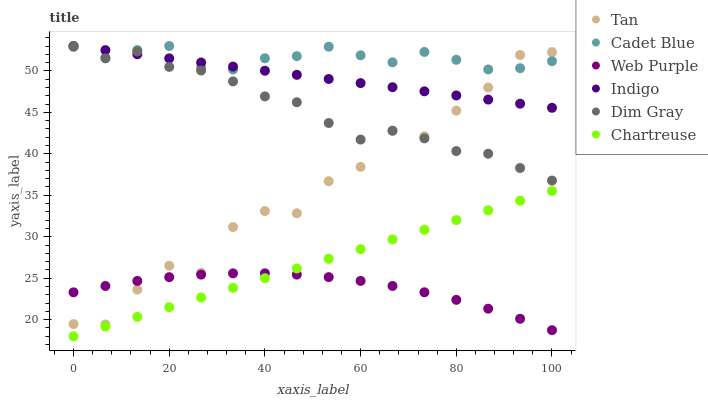Does Web Purple have the minimum area under the curve?
Answer yes or no. Yes. Does Cadet Blue have the maximum area under the curve?
Answer yes or no. Yes. Does Indigo have the minimum area under the curve?
Answer yes or no. No. Does Indigo have the maximum area under the curve?
Answer yes or no. No. Is Indigo the smoothest?
Answer yes or no. Yes. Is Tan the roughest?
Answer yes or no. Yes. Is Web Purple the smoothest?
Answer yes or no. No. Is Web Purple the roughest?
Answer yes or no. No. Does Chartreuse have the lowest value?
Answer yes or no. Yes. Does Indigo have the lowest value?
Answer yes or no. No. Does Dim Gray have the highest value?
Answer yes or no. Yes. Does Web Purple have the highest value?
Answer yes or no. No. Is Chartreuse less than Cadet Blue?
Answer yes or no. Yes. Is Dim Gray greater than Web Purple?
Answer yes or no. Yes. Does Dim Gray intersect Indigo?
Answer yes or no. Yes. Is Dim Gray less than Indigo?
Answer yes or no. No. Is Dim Gray greater than Indigo?
Answer yes or no. No. Does Chartreuse intersect Cadet Blue?
Answer yes or no. No. 